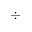<formula> <loc_0><loc_0><loc_500><loc_500>\div</formula> 